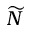<formula> <loc_0><loc_0><loc_500><loc_500>\widetilde { N }</formula> 